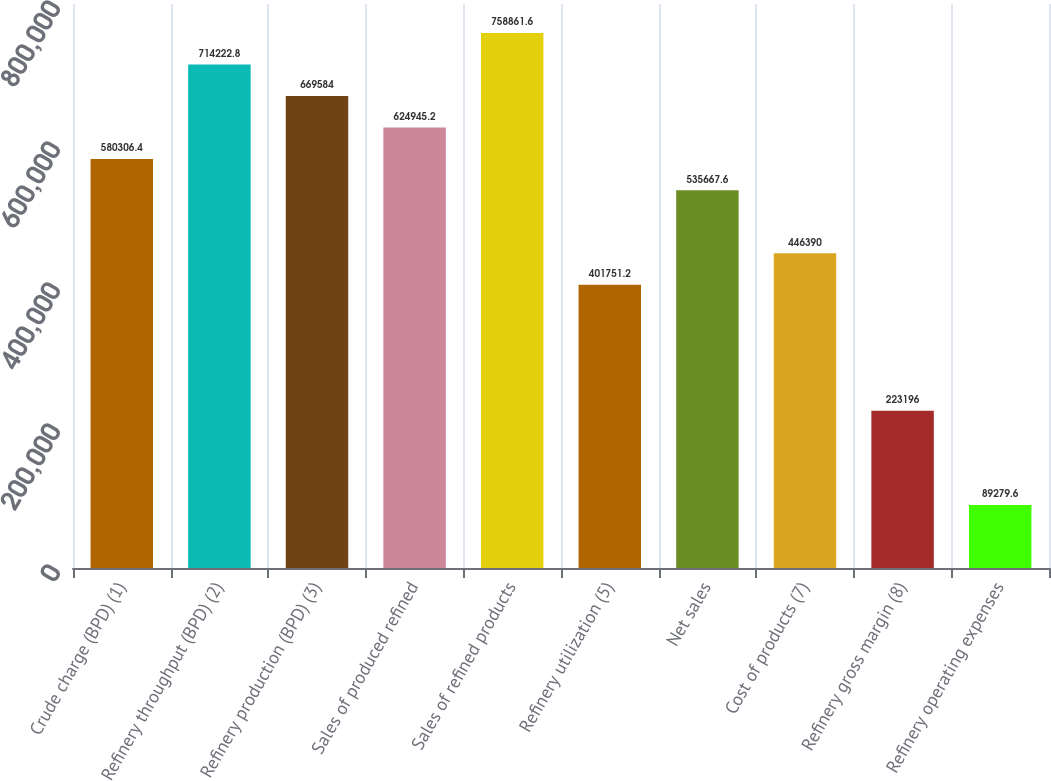Convert chart. <chart><loc_0><loc_0><loc_500><loc_500><bar_chart><fcel>Crude charge (BPD) (1)<fcel>Refinery throughput (BPD) (2)<fcel>Refinery production (BPD) (3)<fcel>Sales of produced refined<fcel>Sales of refined products<fcel>Refinery utilization (5)<fcel>Net sales<fcel>Cost of products (7)<fcel>Refinery gross margin (8)<fcel>Refinery operating expenses<nl><fcel>580306<fcel>714223<fcel>669584<fcel>624945<fcel>758862<fcel>401751<fcel>535668<fcel>446390<fcel>223196<fcel>89279.6<nl></chart> 